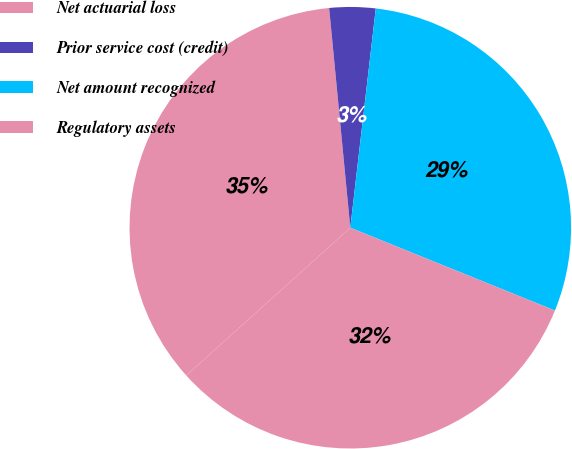Convert chart to OTSL. <chart><loc_0><loc_0><loc_500><loc_500><pie_chart><fcel>Net actuarial loss<fcel>Prior service cost (credit)<fcel>Net amount recognized<fcel>Regulatory assets<nl><fcel>35.14%<fcel>3.37%<fcel>29.28%<fcel>32.21%<nl></chart> 